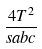<formula> <loc_0><loc_0><loc_500><loc_500>\frac { 4 T ^ { 2 } } { s a b c }</formula> 